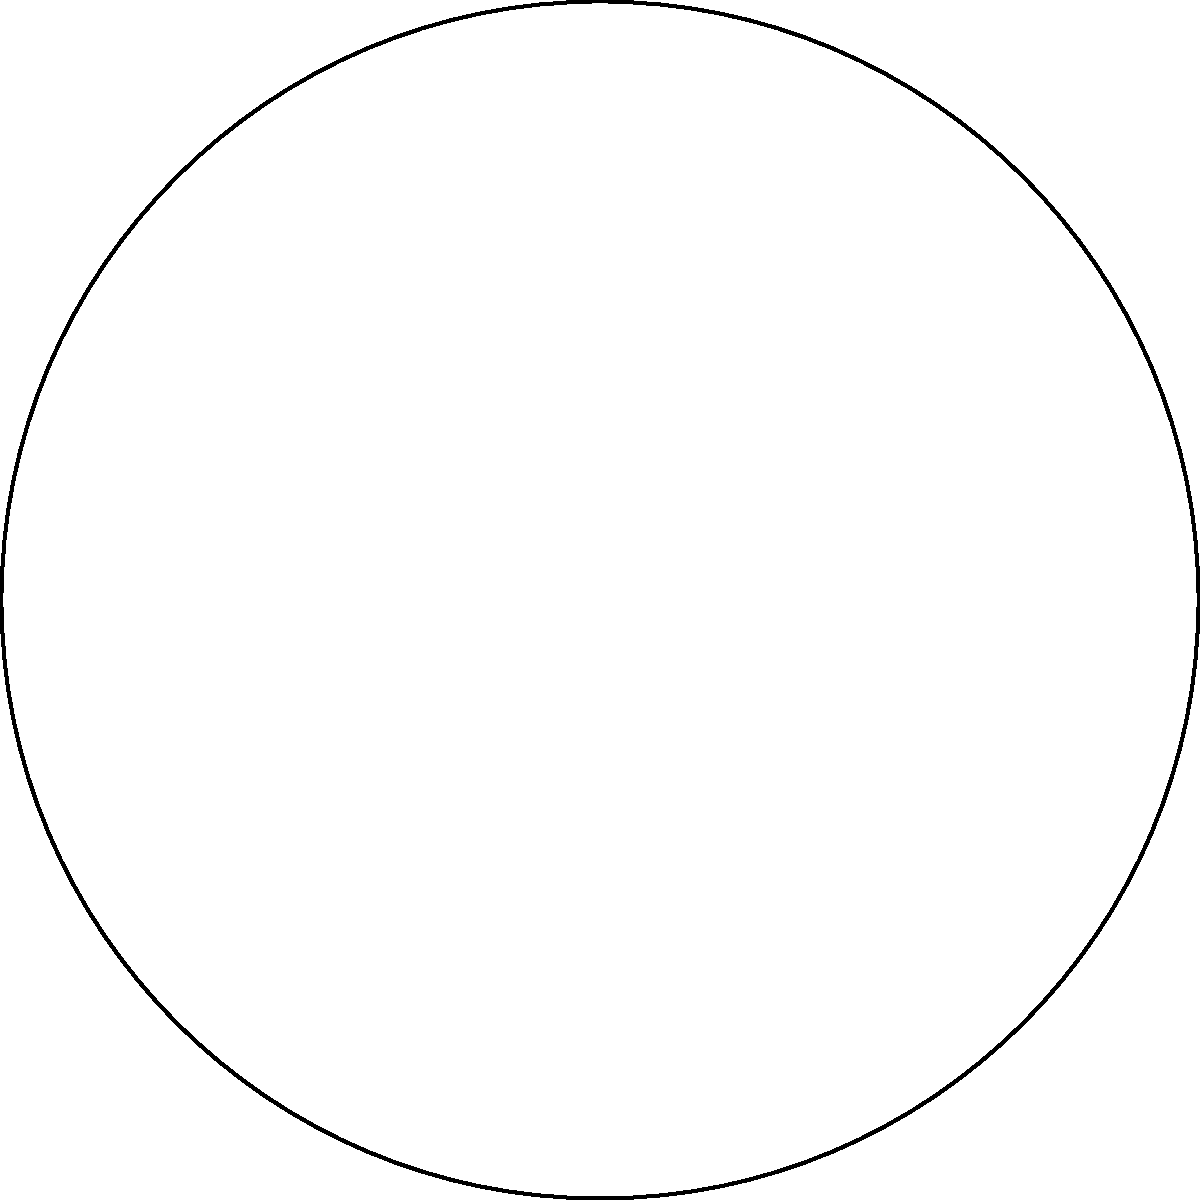In the circular sector OAB representing Hong Kong's legislative districts, the radius OA is 10 cm and the central angle AOB is 90°. Calculate the area of the sector OAB, which symbolizes the proportion of functional constituencies in the Legislative Council. Round your answer to the nearest square centimeter. To find the area of the circular sector OAB, we'll follow these steps:

1) The formula for the area of a circular sector is:
   $$A = \frac{\theta}{360°} \pi r^2$$
   where $\theta$ is the central angle in degrees and $r$ is the radius.

2) We're given:
   - Radius (r) = 10 cm
   - Central angle (θ) = 90°

3) Let's substitute these values into the formula:
   $$A = \frac{90°}{360°} \pi (10\text{ cm})^2$$

4) Simplify:
   $$A = \frac{1}{4} \pi (100\text{ cm}^2)$$
   $$A = 25\pi\text{ cm}^2$$

5) Calculate:
   $$A \approx 78.54\text{ cm}^2$$

6) Rounding to the nearest square centimeter:
   $$A \approx 79\text{ cm}^2$$

This area represents the proportion of functional constituencies in the Legislative Council, which is an important aspect of Hong Kong's political structure.
Answer: 79 cm² 